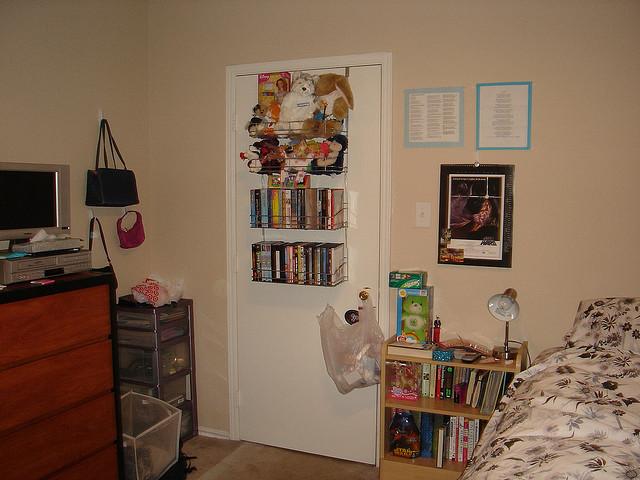What color is the chest of drawers?
Quick response, please. Brown. Is the door open?
Quick response, please. No. Which human gender does this room most likely belong to?
Be succinct. Female. Is the trash bag hanging from the door knob?
Answer briefly. Yes. How many books are in the image?
Be succinct. My best guess is 40. Is the door shut?
Keep it brief. Yes. What is the color of the drawers?
Short answer required. Brown. 